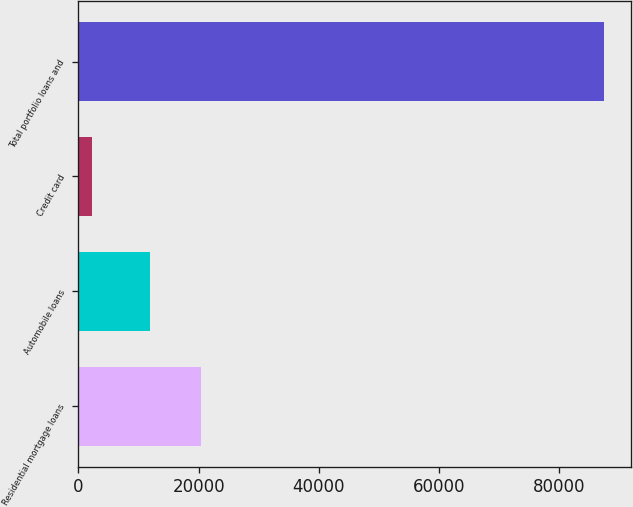Convert chart to OTSL. <chart><loc_0><loc_0><loc_500><loc_500><bar_chart><fcel>Residential mortgage loans<fcel>Automobile loans<fcel>Credit card<fcel>Total portfolio loans and<nl><fcel>20449.9<fcel>11919<fcel>2225<fcel>87534<nl></chart> 